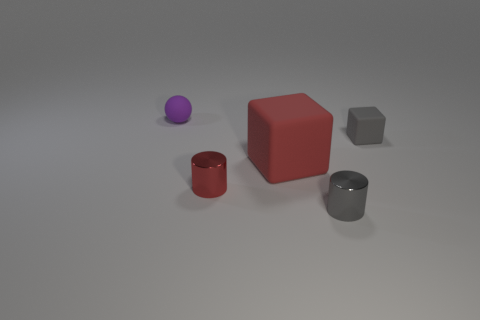What number of other objects are there of the same color as the large matte object?
Your response must be concise. 1. What is the color of the tiny object that is both behind the red matte object and left of the gray cube?
Offer a very short reply. Purple. How many gray rubber things are there?
Keep it short and to the point. 1. Do the purple object and the large thing have the same material?
Your answer should be very brief. Yes. What shape is the shiny thing on the left side of the cube in front of the block on the right side of the small gray metallic cylinder?
Provide a short and direct response. Cylinder. Do the gray thing behind the small gray shiny thing and the tiny cylinder behind the tiny gray metallic object have the same material?
Your response must be concise. No. What is the gray cylinder made of?
Provide a short and direct response. Metal. What number of tiny gray objects are the same shape as the small red thing?
Offer a terse response. 1. There is a tiny thing that is the same color as the small block; what material is it?
Provide a succinct answer. Metal. Is there any other thing that has the same shape as the small gray metallic object?
Provide a short and direct response. Yes. 